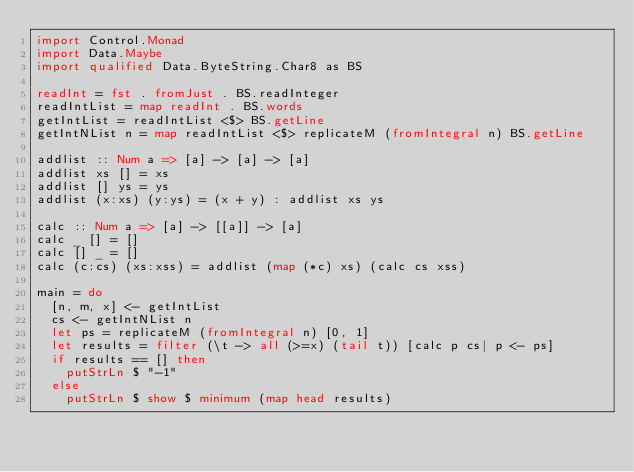Convert code to text. <code><loc_0><loc_0><loc_500><loc_500><_Haskell_>import Control.Monad
import Data.Maybe
import qualified Data.ByteString.Char8 as BS

readInt = fst . fromJust . BS.readInteger
readIntList = map readInt . BS.words
getIntList = readIntList <$> BS.getLine
getIntNList n = map readIntList <$> replicateM (fromIntegral n) BS.getLine

addlist :: Num a => [a] -> [a] -> [a]
addlist xs [] = xs
addlist [] ys = ys
addlist (x:xs) (y:ys) = (x + y) : addlist xs ys

calc :: Num a => [a] -> [[a]] -> [a]
calc _ [] = []
calc [] _ = []
calc (c:cs) (xs:xss) = addlist (map (*c) xs) (calc cs xss) 

main = do
  [n, m, x] <- getIntList
  cs <- getIntNList n
  let ps = replicateM (fromIntegral n) [0, 1]
  let results = filter (\t -> all (>=x) (tail t)) [calc p cs| p <- ps]
  if results == [] then
  	putStrLn $ "-1"
  else
    putStrLn $ show $ minimum (map head results)
    </code> 